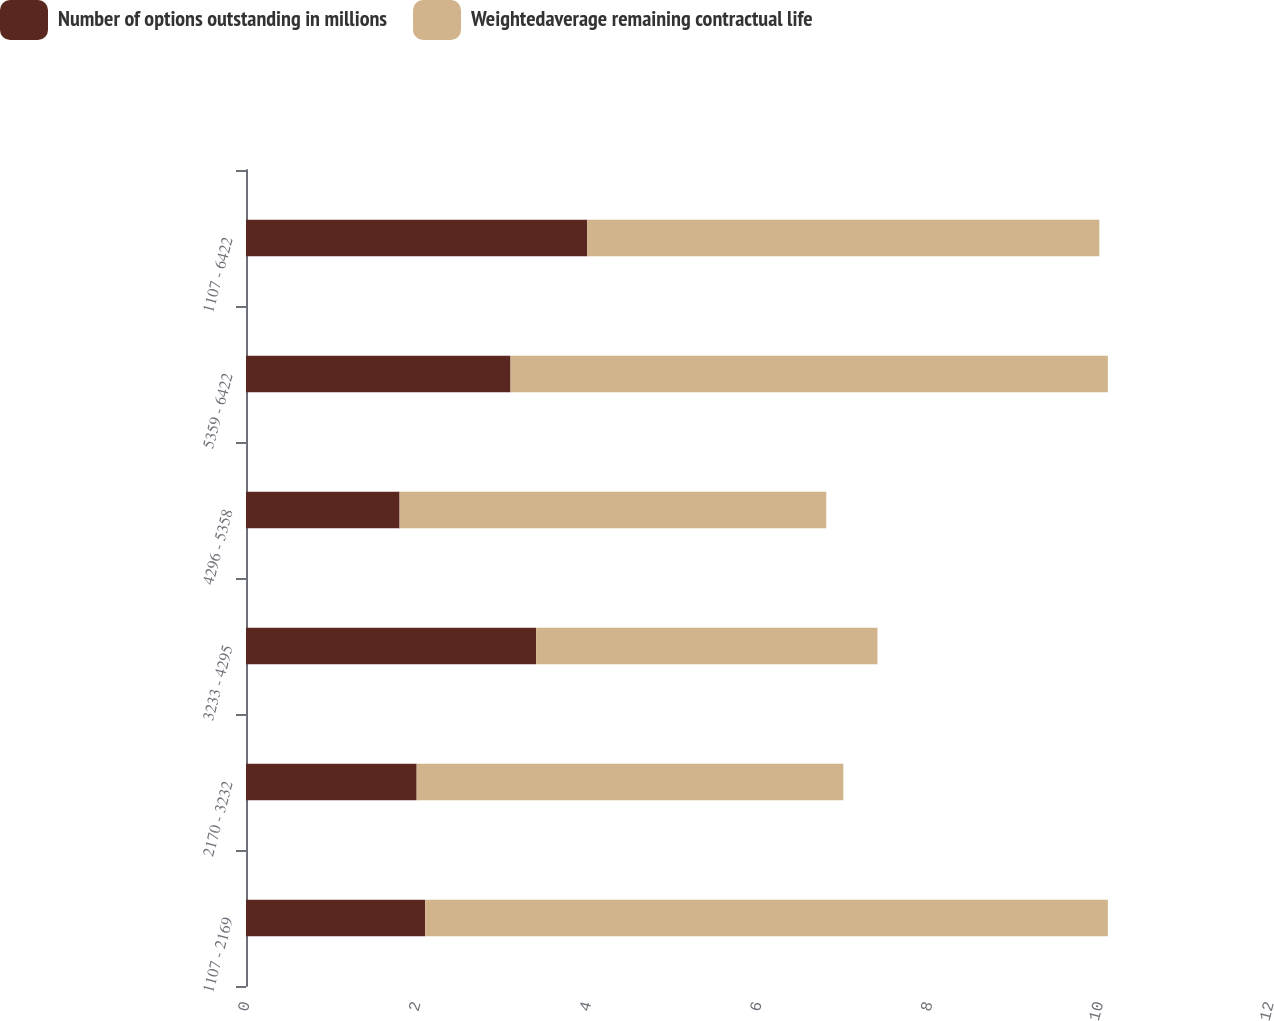Convert chart to OTSL. <chart><loc_0><loc_0><loc_500><loc_500><stacked_bar_chart><ecel><fcel>1107 - 2169<fcel>2170 - 3232<fcel>3233 - 4295<fcel>4296 - 5358<fcel>5359 - 6422<fcel>1107 - 6422<nl><fcel>Number of options outstanding in millions<fcel>2.1<fcel>2<fcel>3.4<fcel>1.8<fcel>3.1<fcel>4<nl><fcel>Weightedaverage remaining contractual life<fcel>8<fcel>5<fcel>4<fcel>5<fcel>7<fcel>6<nl></chart> 